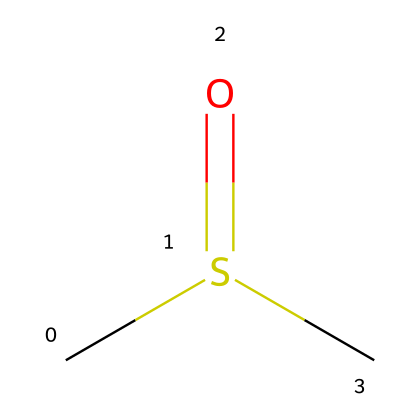What is the molecular formula of dimethyl sulfoxide? The SMILES representation shows two carbon (C) atoms, one sulfur (S) atom, and one oxygen (O) atom, leading to the molecular formula C2H6OS.
Answer: C2H6OS How many carbon atoms are present in the structure? Counting from the SMILES, there are two carbon (C) atoms indicated in the structure, specifically before the sulfur (S).
Answer: 2 What is the hybridization of the sulfur atom in DMSO? In the structure, the sulfur atom has one double bond (to oxygen) and two single bonds (to carbon) based on the connections shown in the SMILES. This indicates the sulfur atom is sp2 hybridized.
Answer: sp2 What functional group is present in dimethyl sulfoxide? The SMILES demonstrates a sulfoxide group (R1-S(=O)-R2), where the sulfur is bonded to an oxygen with a double bond and is also bonded to carbon atoms, making it a sulfoxide.
Answer: sulfoxide What is the total number of hydrogen atoms in the structure? The SMILES indicates that there are six hydrogen (H) atoms bonded to the two carbon atoms, leading to a total of six hydrogens in the full structure.
Answer: 6 Why is DMSO considered a polar aprotic solvent? The DMSO structure shows a significant dipole due to the sulfur-oxygen bond and lacks an acidic hydrogen, fitting the definition of a polar aprotic solvent where it can dissolve ionic compounds without donating protons.
Answer: polar aprotic 